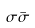<formula> <loc_0><loc_0><loc_500><loc_500>\sigma \bar { \sigma }</formula> 